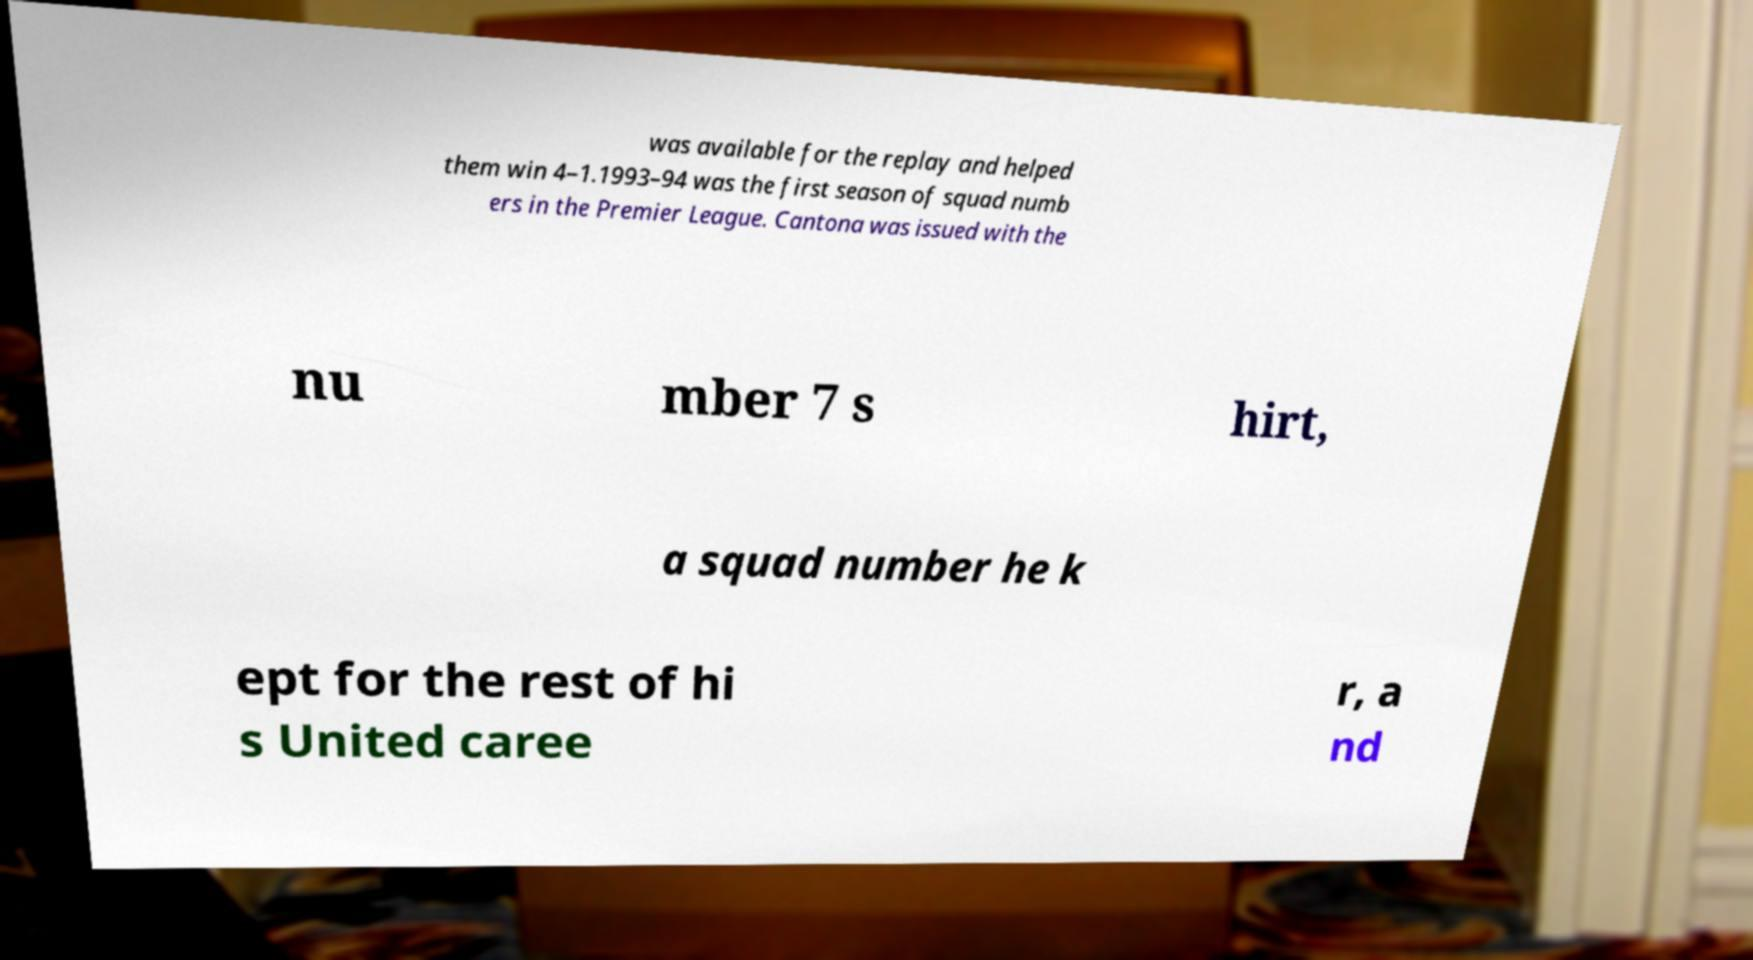For documentation purposes, I need the text within this image transcribed. Could you provide that? was available for the replay and helped them win 4–1.1993–94 was the first season of squad numb ers in the Premier League. Cantona was issued with the nu mber 7 s hirt, a squad number he k ept for the rest of hi s United caree r, a nd 